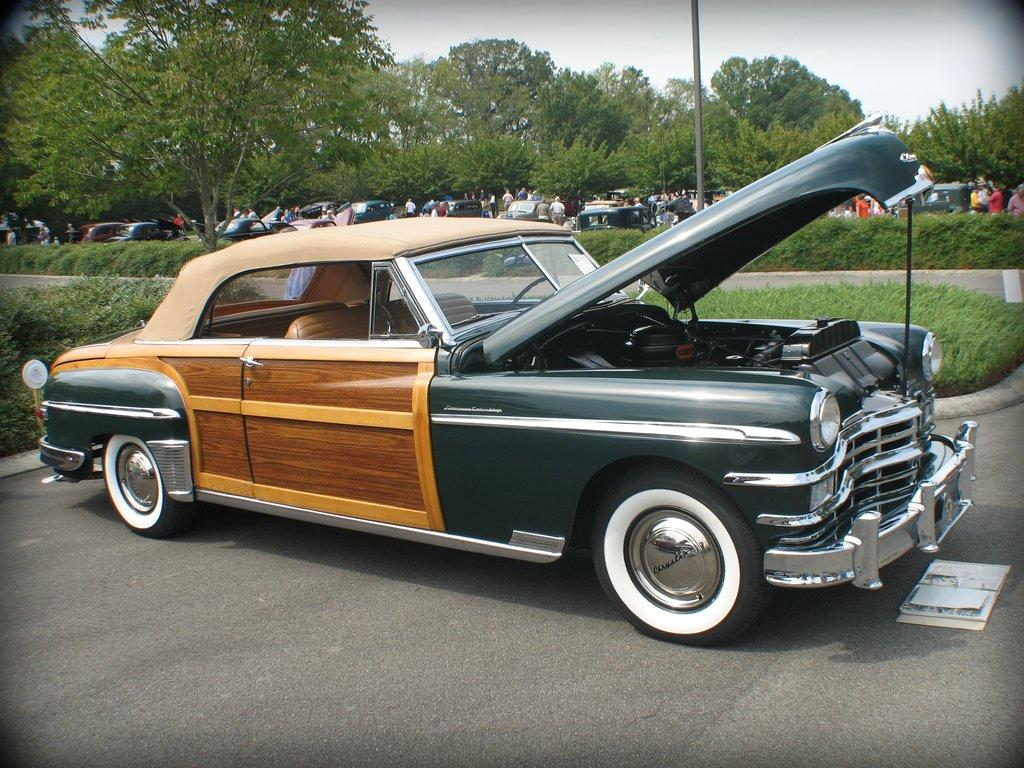What is the main subject in the center of the image? There is a car in the center of the image. What can be seen in the background of the image? There are trees and persons in the background of the image. Are there any other vehicles visible in the image? Yes, there are vehicles in the background of the image. What type of ground surface is visible in the image? There is grass on the ground in the image. What type of jewel is being used to open the car door in the image? There is no jewel present in the image, and the car door is not being opened. 